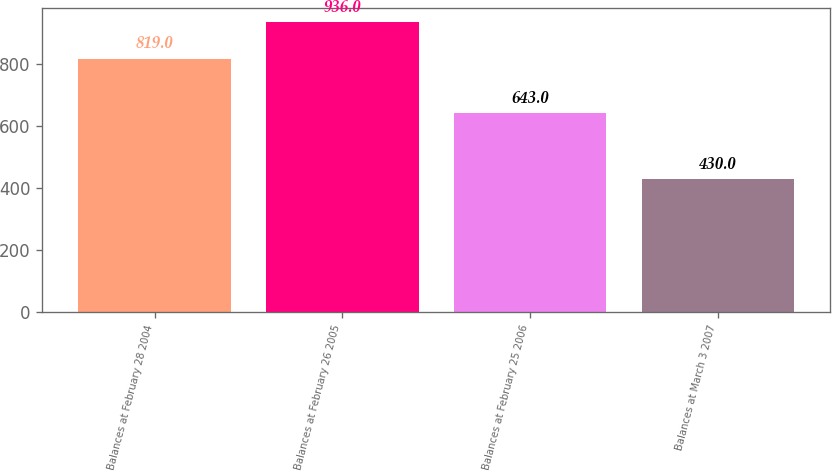Convert chart to OTSL. <chart><loc_0><loc_0><loc_500><loc_500><bar_chart><fcel>Balances at February 28 2004<fcel>Balances at February 26 2005<fcel>Balances at February 25 2006<fcel>Balances at March 3 2007<nl><fcel>819<fcel>936<fcel>643<fcel>430<nl></chart> 